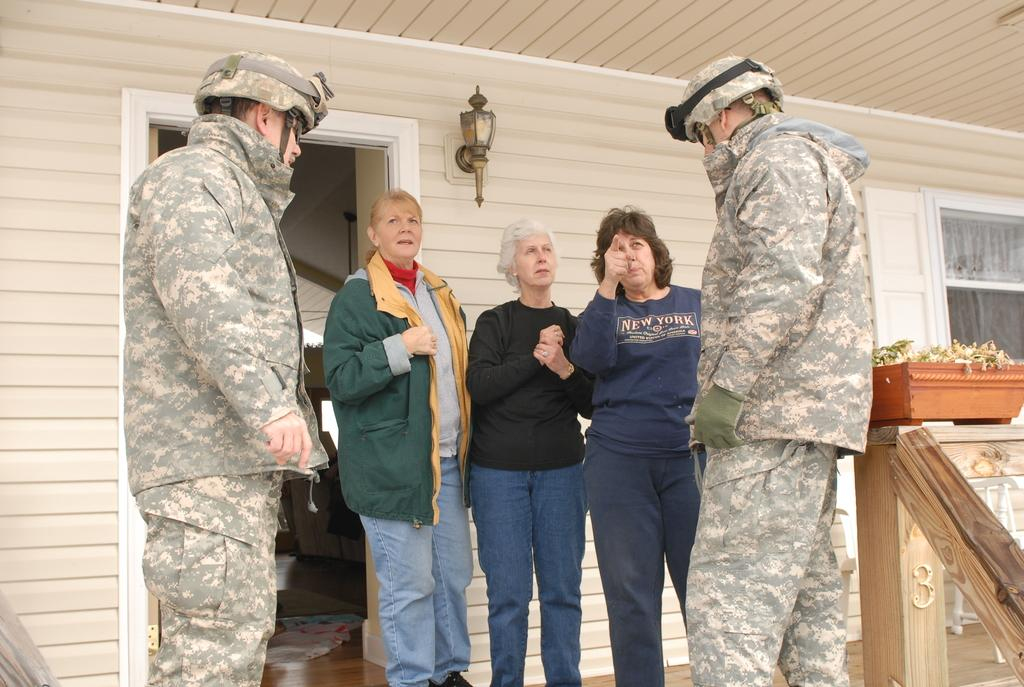What is located in the foreground of the image? In the foreground of the image, there are army men, people, a plant pot, and a railing. Can you describe the objects in the background of the image? In the background of the image, there is a door, a window, a lamp, and other objects. Is there any smoke coming from the lamp in the image? There is no smoke present in the image, and the lamp does not appear to be emitting any smoke. What type of office furniture can be seen in the image? There is no office furniture present in the image. 